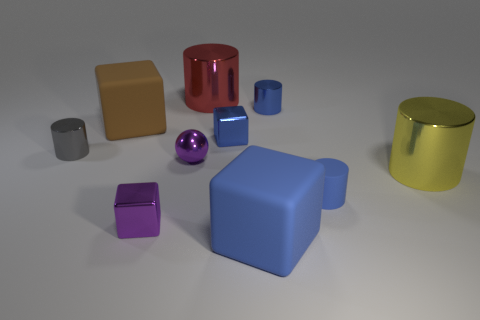What shape is the big thing right of the large rubber thing that is right of the blue cube that is behind the gray thing?
Your answer should be very brief. Cylinder. Is the number of big cyan things greater than the number of big yellow metallic cylinders?
Keep it short and to the point. No. Is there a blue matte cylinder?
Offer a terse response. Yes. What number of objects are tiny cubes to the right of the purple metal block or big metallic cylinders that are behind the gray metallic object?
Your answer should be very brief. 2. Does the small matte cylinder have the same color as the small shiny sphere?
Keep it short and to the point. No. Are there fewer small cyan objects than tiny things?
Ensure brevity in your answer.  Yes. There is a big blue rubber thing; are there any tiny rubber things on the left side of it?
Your answer should be compact. No. Are the gray object and the purple block made of the same material?
Give a very brief answer. Yes. There is another big object that is the same shape as the big red thing; what is its color?
Provide a succinct answer. Yellow. There is a tiny rubber object that is behind the large blue block; is it the same color as the ball?
Your answer should be compact. No. 